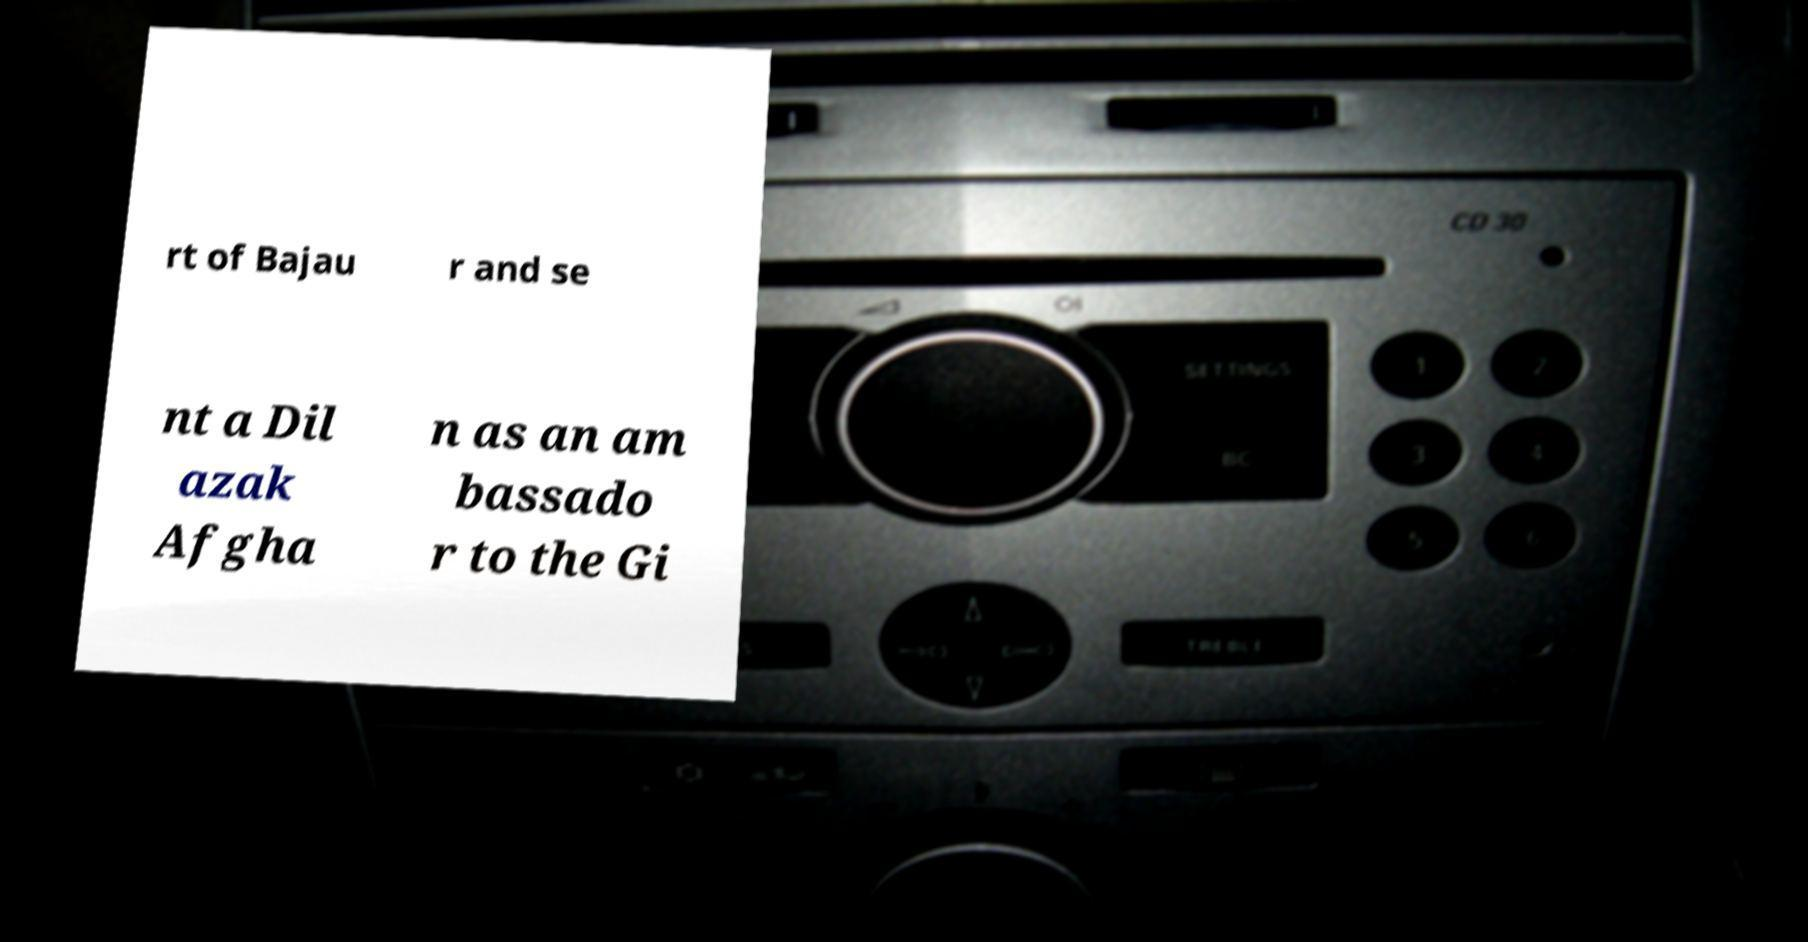Could you assist in decoding the text presented in this image and type it out clearly? rt of Bajau r and se nt a Dil azak Afgha n as an am bassado r to the Gi 